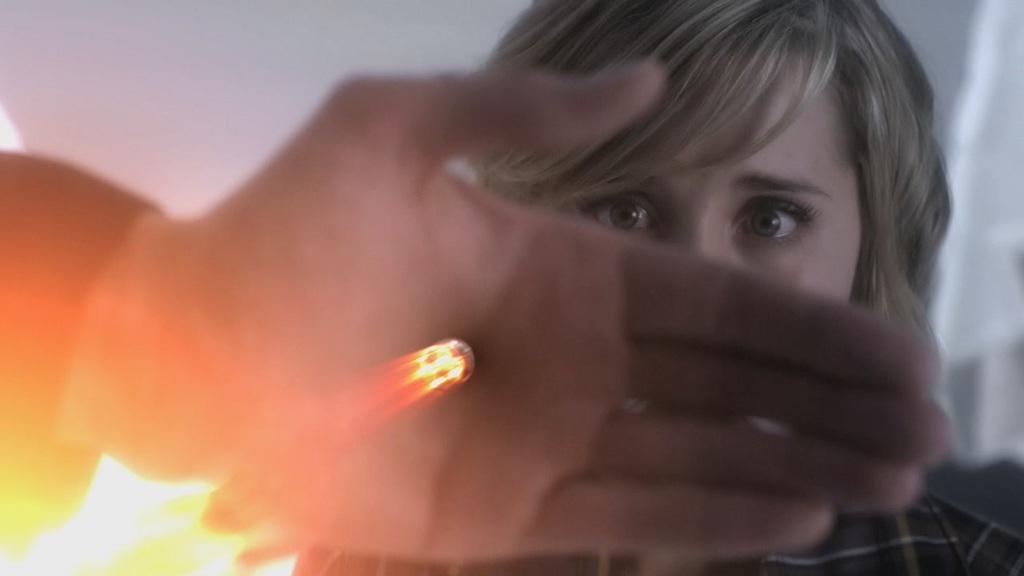Describe this image in one or two sentences. In this picture I can see a person, there is a hand of a person, and there is blur background. 